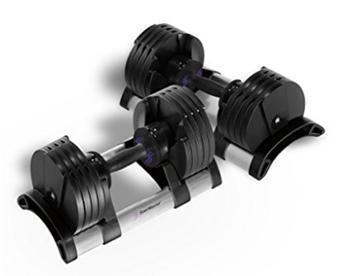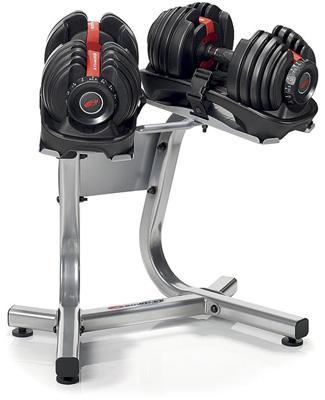The first image is the image on the left, the second image is the image on the right. Considering the images on both sides, is "A person is interacting with the weights in the image on the right." valid? Answer yes or no. No. The first image is the image on the left, the second image is the image on the right. For the images displayed, is the sentence "A person is touching the dumbbells in the right image only." factually correct? Answer yes or no. No. 